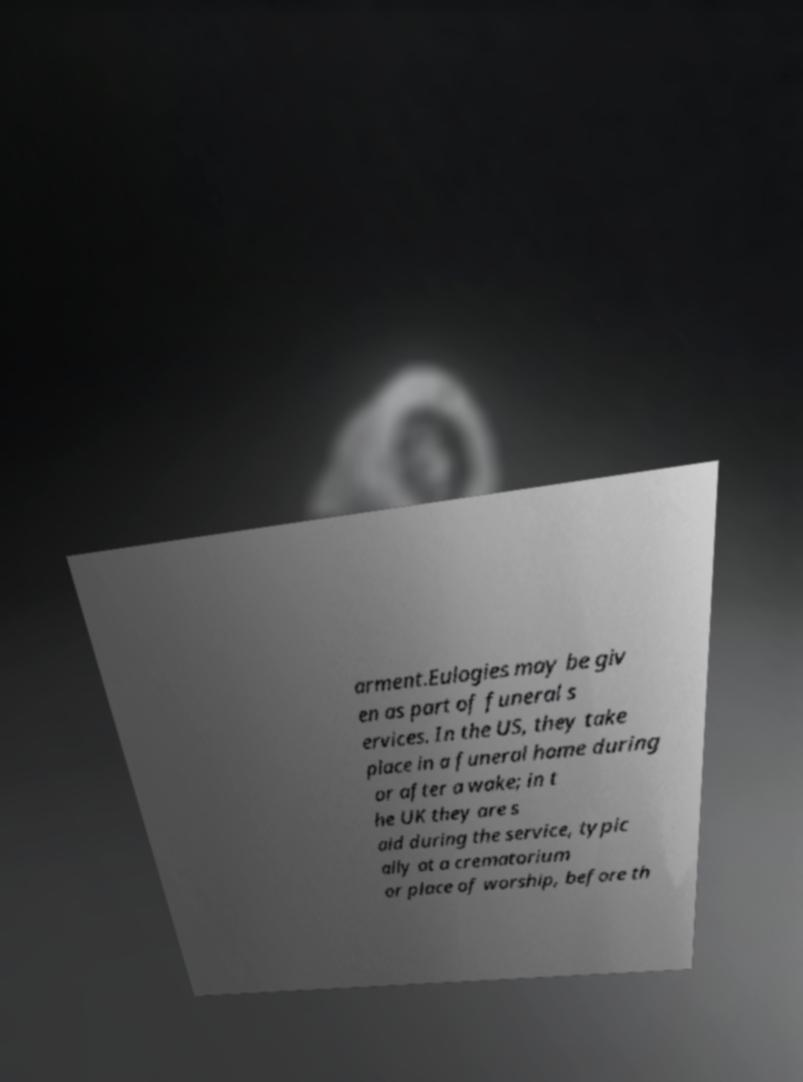For documentation purposes, I need the text within this image transcribed. Could you provide that? arment.Eulogies may be giv en as part of funeral s ervices. In the US, they take place in a funeral home during or after a wake; in t he UK they are s aid during the service, typic ally at a crematorium or place of worship, before th 